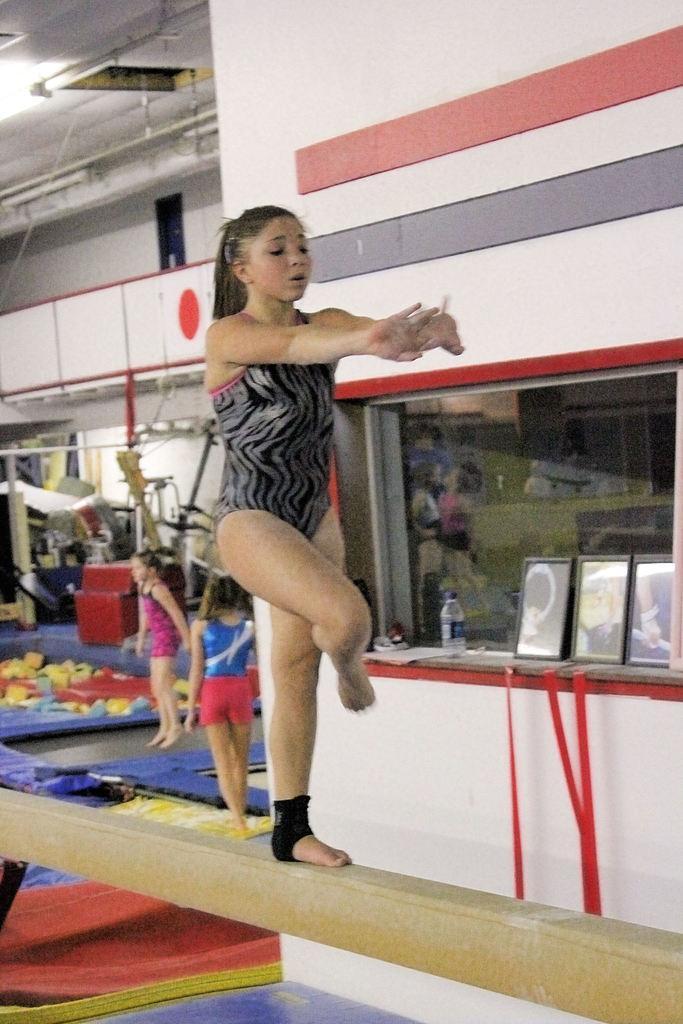How would you summarize this image in a sentence or two? In this picture I can see a woman standing on the wood and I can see couple of women and few machines in the back. I can see a light to the ceiling and few cupboards. I can see few photo frames and a bottle. 